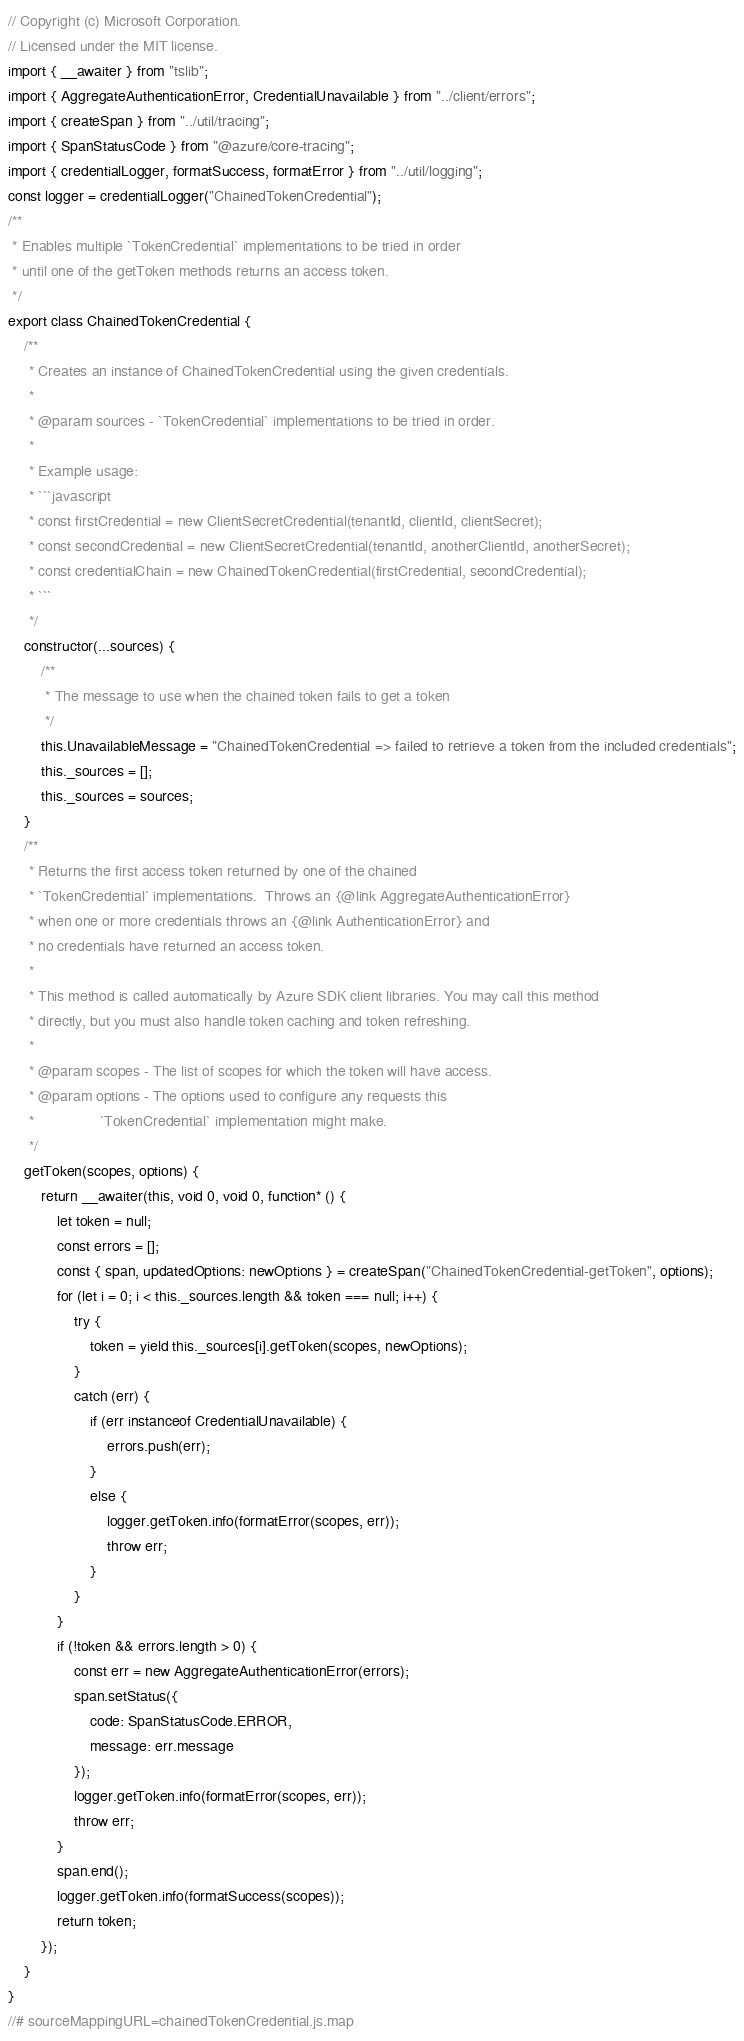<code> <loc_0><loc_0><loc_500><loc_500><_JavaScript_>// Copyright (c) Microsoft Corporation.
// Licensed under the MIT license.
import { __awaiter } from "tslib";
import { AggregateAuthenticationError, CredentialUnavailable } from "../client/errors";
import { createSpan } from "../util/tracing";
import { SpanStatusCode } from "@azure/core-tracing";
import { credentialLogger, formatSuccess, formatError } from "../util/logging";
const logger = credentialLogger("ChainedTokenCredential");
/**
 * Enables multiple `TokenCredential` implementations to be tried in order
 * until one of the getToken methods returns an access token.
 */
export class ChainedTokenCredential {
    /**
     * Creates an instance of ChainedTokenCredential using the given credentials.
     *
     * @param sources - `TokenCredential` implementations to be tried in order.
     *
     * Example usage:
     * ```javascript
     * const firstCredential = new ClientSecretCredential(tenantId, clientId, clientSecret);
     * const secondCredential = new ClientSecretCredential(tenantId, anotherClientId, anotherSecret);
     * const credentialChain = new ChainedTokenCredential(firstCredential, secondCredential);
     * ```
     */
    constructor(...sources) {
        /**
         * The message to use when the chained token fails to get a token
         */
        this.UnavailableMessage = "ChainedTokenCredential => failed to retrieve a token from the included credentials";
        this._sources = [];
        this._sources = sources;
    }
    /**
     * Returns the first access token returned by one of the chained
     * `TokenCredential` implementations.  Throws an {@link AggregateAuthenticationError}
     * when one or more credentials throws an {@link AuthenticationError} and
     * no credentials have returned an access token.
     *
     * This method is called automatically by Azure SDK client libraries. You may call this method
     * directly, but you must also handle token caching and token refreshing.
     *
     * @param scopes - The list of scopes for which the token will have access.
     * @param options - The options used to configure any requests this
     *                `TokenCredential` implementation might make.
     */
    getToken(scopes, options) {
        return __awaiter(this, void 0, void 0, function* () {
            let token = null;
            const errors = [];
            const { span, updatedOptions: newOptions } = createSpan("ChainedTokenCredential-getToken", options);
            for (let i = 0; i < this._sources.length && token === null; i++) {
                try {
                    token = yield this._sources[i].getToken(scopes, newOptions);
                }
                catch (err) {
                    if (err instanceof CredentialUnavailable) {
                        errors.push(err);
                    }
                    else {
                        logger.getToken.info(formatError(scopes, err));
                        throw err;
                    }
                }
            }
            if (!token && errors.length > 0) {
                const err = new AggregateAuthenticationError(errors);
                span.setStatus({
                    code: SpanStatusCode.ERROR,
                    message: err.message
                });
                logger.getToken.info(formatError(scopes, err));
                throw err;
            }
            span.end();
            logger.getToken.info(formatSuccess(scopes));
            return token;
        });
    }
}
//# sourceMappingURL=chainedTokenCredential.js.map</code> 